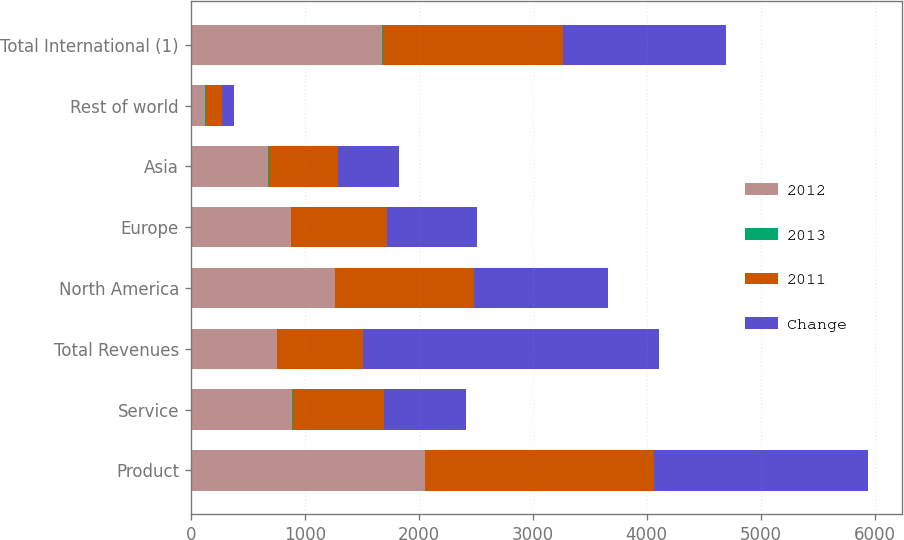Convert chart. <chart><loc_0><loc_0><loc_500><loc_500><stacked_bar_chart><ecel><fcel>Product<fcel>Service<fcel>Total Revenues<fcel>North America<fcel>Europe<fcel>Asia<fcel>Rest of world<fcel>Total International (1)<nl><fcel>2012<fcel>2056<fcel>887<fcel>753<fcel>1263<fcel>877<fcel>678<fcel>125<fcel>1680<nl><fcel>2013<fcel>3<fcel>10<fcel>5<fcel>3<fcel>4<fcel>13<fcel>11<fcel>6<nl><fcel>2011<fcel>2004<fcel>803<fcel>753<fcel>1223<fcel>842<fcel>602<fcel>140<fcel>1584<nl><fcel>Change<fcel>1879<fcel>718<fcel>2597<fcel>1170<fcel>788<fcel>537<fcel>102<fcel>1427<nl></chart> 